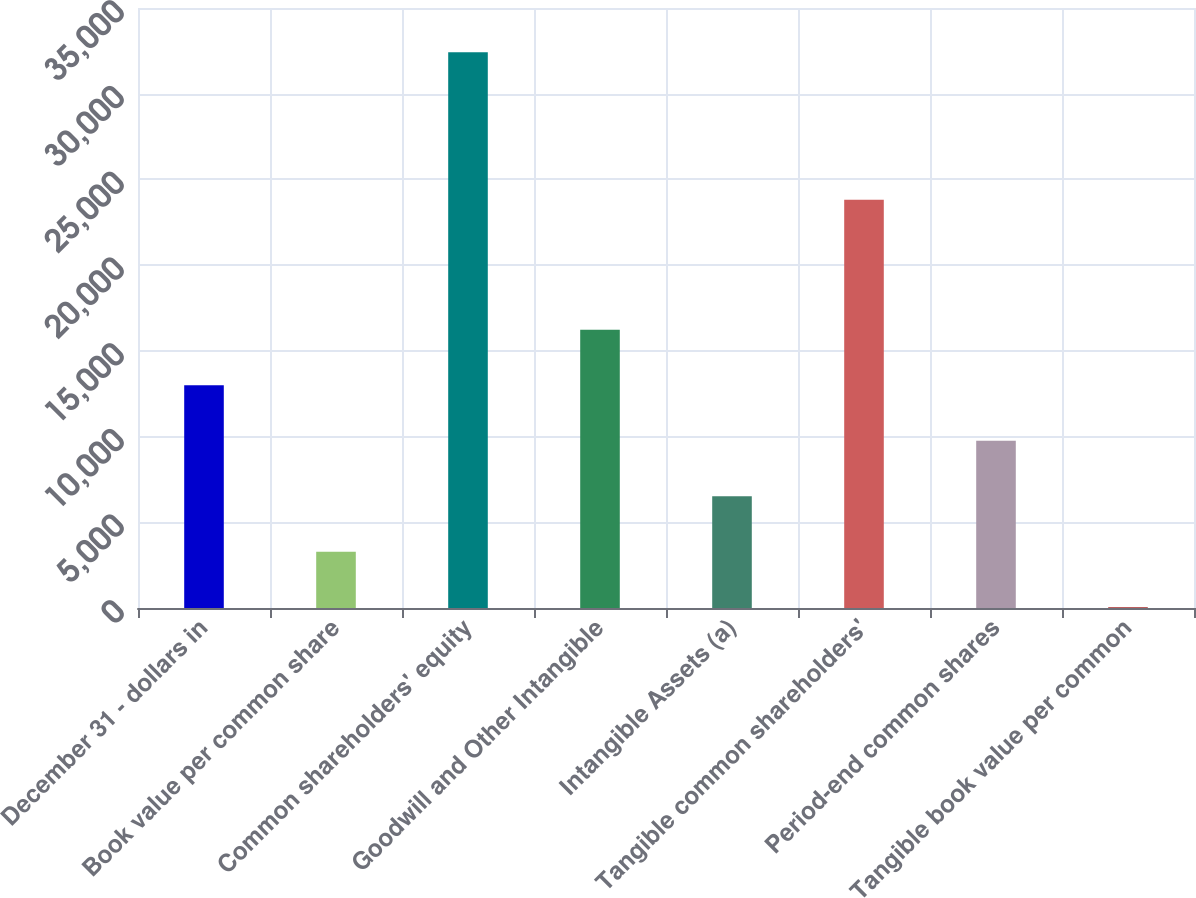Convert chart to OTSL. <chart><loc_0><loc_0><loc_500><loc_500><bar_chart><fcel>December 31 - dollars in<fcel>Book value per common share<fcel>Common shareholders' equity<fcel>Goodwill and Other Intangible<fcel>Intangible Assets (a)<fcel>Tangible common shareholders'<fcel>Period-end common shares<fcel>Tangible book value per common<nl><fcel>12993.9<fcel>3282.38<fcel>32417<fcel>16231.1<fcel>6519.56<fcel>23821<fcel>9756.74<fcel>45.2<nl></chart> 